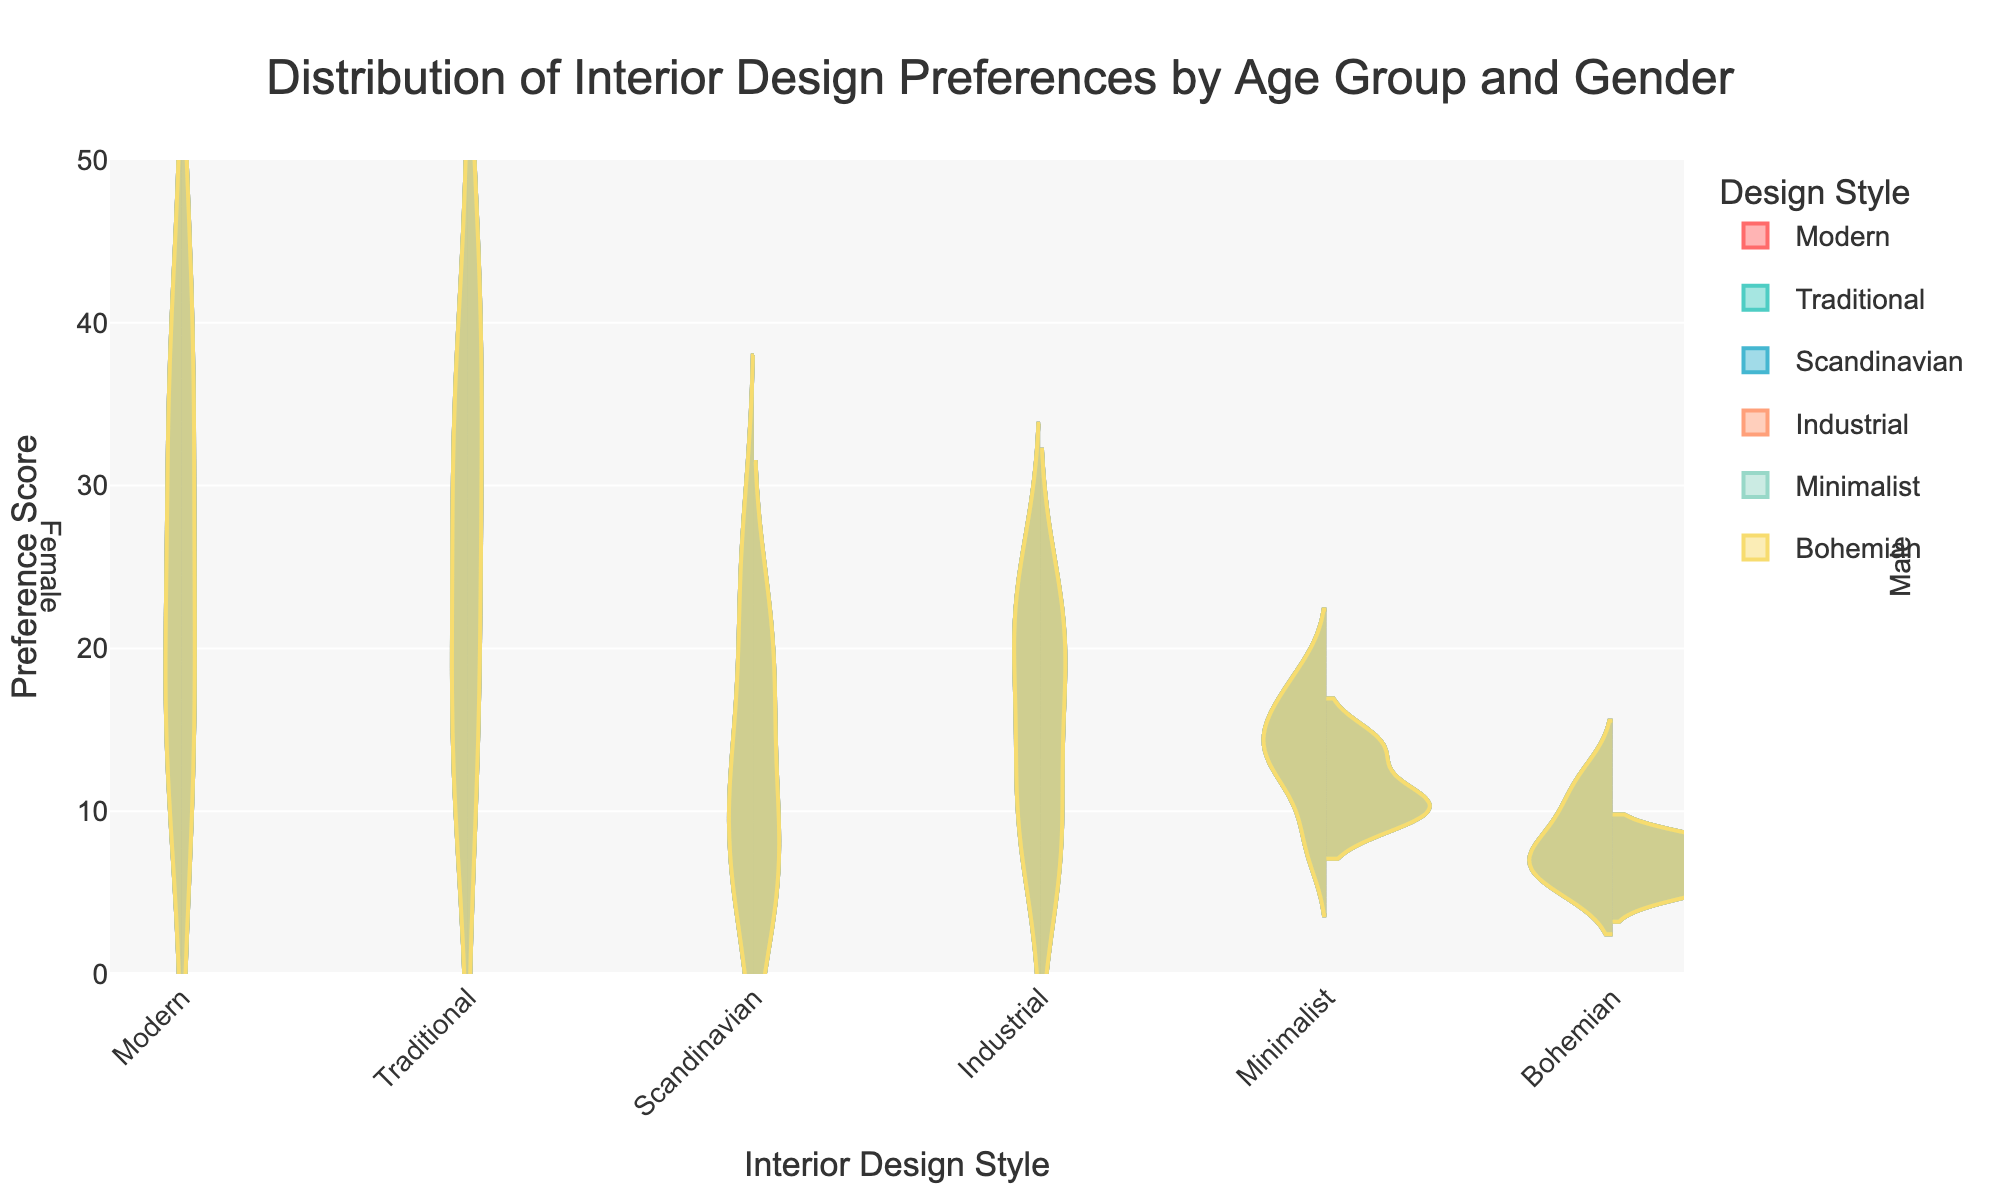Which age group prefers Modern design the most among males? The violin plot shows the distribution of preferences. By examining the height and width of the violins, it's evident that males in the 18-24 age group have the highest peak for Modern design.
Answer: 18-24 What's the combined preference score for Traditional design among females aged 18-24 and 25-34? From the figure, the preference scores for Traditional design in the 18-24 and 25-34 female age groups are 10 and 15, respectively. Adding them gives us 10 + 15 = 25.
Answer: 25 Between Industrial and Minimalist styles, which one shows lesser preference among males aged 35-44? By comparing the widths of the violins for both styles for males aged 35-44, the violin for Minimalist is narrower compared to Industrial, indicating a lower preference score.
Answer: Minimalist How does the preference for Bohemian design change from the 25-34 to the 35-44 age group for females? The violin plot for females shows that in the 25-34 age group, the preference score for Bohemian is represented by a wider distribution compared to the 35-44 age group, indicating that preference decreases.
Answer: Decreases Is the preference for Scandinavian design among males more consistent across age groups compared to females? The width of the violins for males in different age groups is relatively consistent for Scandinavian design, whereas for females, there is more variance in the widths of the violins across age groups, indicating more fluctuation.
Answer: Yes Which gender prefers Industrial design more in the 45-54 age group? The violin plot reveals that both males and females show preferences in the 45-54 age group, but the male distribution is wider, indicating higher preference.
Answer: Male For which gender and age group is the preference score for Minimalist design the highest? By looking at the violin plot heights, the female 35-44 age group shows a peak for Minimalist that is higher than other age groups and genders.
Answer: Female 35-44 Comparing the preference for Traditional design, which age group shows the largest difference between males and females? Observing the height and widths of violins, the 18-24 age group shows a significant difference, with males having a relatively high preference and females having the lowest.
Answer: 18-24 